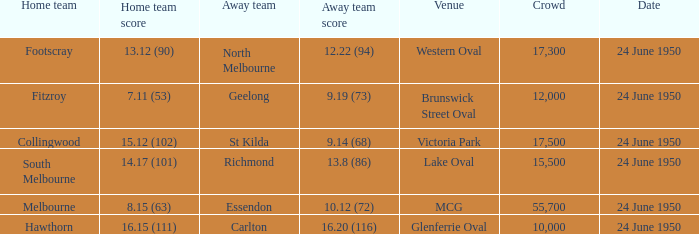Who was the home team for the game where North Melbourne was the away team and the crowd was over 12,000? Footscray. 